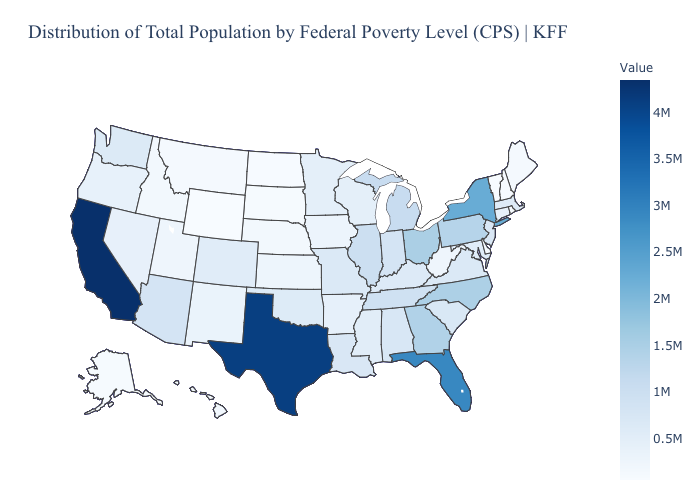Among the states that border South Dakota , which have the lowest value?
Short answer required. Wyoming. Which states hav the highest value in the South?
Short answer required. Texas. Does Alaska have a higher value than Kentucky?
Give a very brief answer. No. Among the states that border North Dakota , which have the highest value?
Short answer required. Minnesota. Among the states that border New Mexico , which have the lowest value?
Be succinct. Utah. Is the legend a continuous bar?
Concise answer only. Yes. 